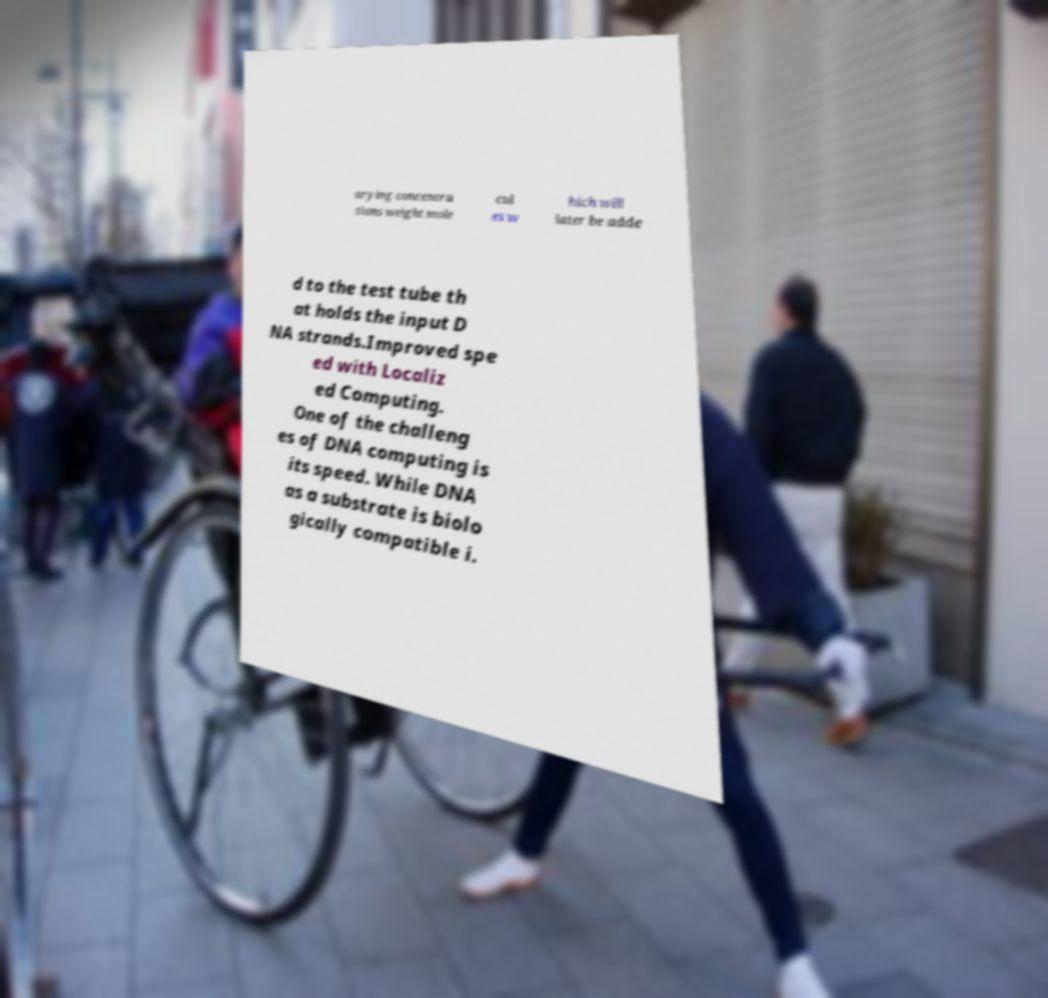I need the written content from this picture converted into text. Can you do that? arying concentra tions weight mole cul es w hich will later be adde d to the test tube th at holds the input D NA strands.Improved spe ed with Localiz ed Computing. One of the challeng es of DNA computing is its speed. While DNA as a substrate is biolo gically compatible i. 